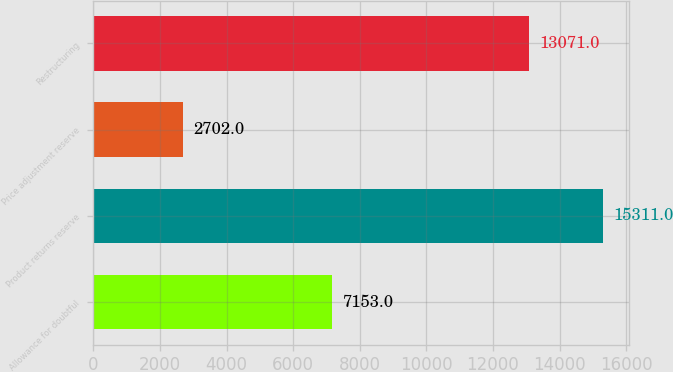Convert chart. <chart><loc_0><loc_0><loc_500><loc_500><bar_chart><fcel>Allowance for doubtful<fcel>Product returns reserve<fcel>Price adjustment reserve<fcel>Restructuring<nl><fcel>7153<fcel>15311<fcel>2702<fcel>13071<nl></chart> 